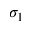<formula> <loc_0><loc_0><loc_500><loc_500>\sigma _ { 1 }</formula> 